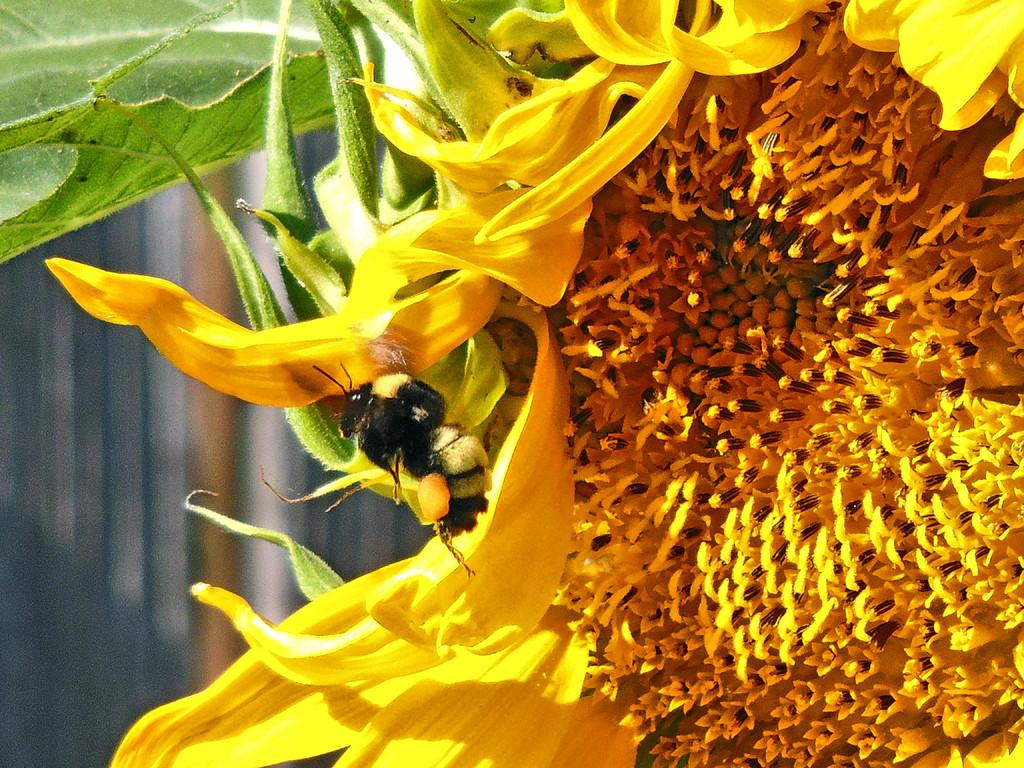What type of insect is present in the image? There is a honeybee in the image. What is the honeybee interacting with in the image? The honeybee is interacting with a yellow color flower in the image. Can you describe the background of the image? The background of the image is blurred. What type of hair product is being advertised in the image? There is no hair product or advertisement present in the image; it features a honeybee and a yellow flower. What type of shop can be seen in the background of the image? There is no shop visible in the image; the background is blurred. 